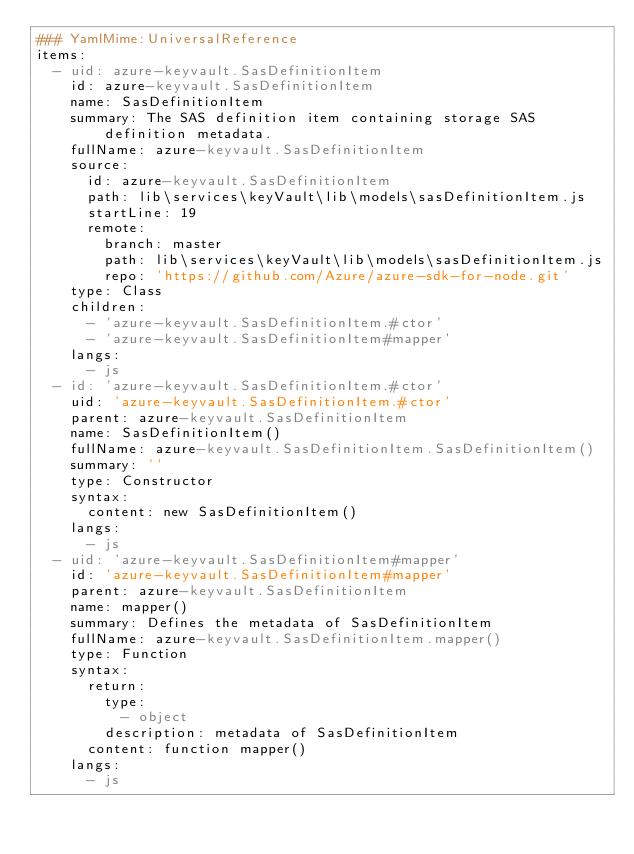<code> <loc_0><loc_0><loc_500><loc_500><_YAML_>### YamlMime:UniversalReference
items:
  - uid: azure-keyvault.SasDefinitionItem
    id: azure-keyvault.SasDefinitionItem
    name: SasDefinitionItem
    summary: The SAS definition item containing storage SAS definition metadata.
    fullName: azure-keyvault.SasDefinitionItem
    source:
      id: azure-keyvault.SasDefinitionItem
      path: lib\services\keyVault\lib\models\sasDefinitionItem.js
      startLine: 19
      remote:
        branch: master
        path: lib\services\keyVault\lib\models\sasDefinitionItem.js
        repo: 'https://github.com/Azure/azure-sdk-for-node.git'
    type: Class
    children:
      - 'azure-keyvault.SasDefinitionItem.#ctor'
      - 'azure-keyvault.SasDefinitionItem#mapper'
    langs:
      - js
  - id: 'azure-keyvault.SasDefinitionItem.#ctor'
    uid: 'azure-keyvault.SasDefinitionItem.#ctor'
    parent: azure-keyvault.SasDefinitionItem
    name: SasDefinitionItem()
    fullName: azure-keyvault.SasDefinitionItem.SasDefinitionItem()
    summary: ''
    type: Constructor
    syntax:
      content: new SasDefinitionItem()
    langs:
      - js
  - uid: 'azure-keyvault.SasDefinitionItem#mapper'
    id: 'azure-keyvault.SasDefinitionItem#mapper'
    parent: azure-keyvault.SasDefinitionItem
    name: mapper()
    summary: Defines the metadata of SasDefinitionItem
    fullName: azure-keyvault.SasDefinitionItem.mapper()
    type: Function
    syntax:
      return:
        type:
          - object
        description: metadata of SasDefinitionItem
      content: function mapper()
    langs:
      - js
</code> 